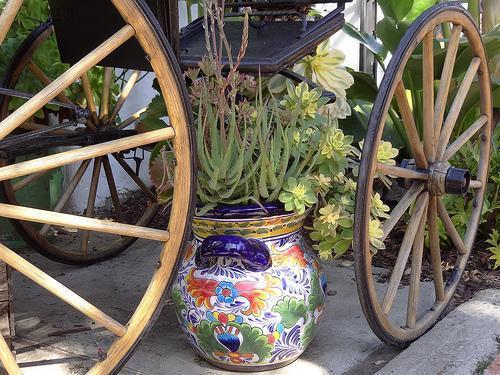How many pots?
Give a very brief answer. 1. How many wheels?
Give a very brief answer. 3. How many wheels are pictured?
Give a very brief answer. 3. How many wheels are there?
Give a very brief answer. 3. 